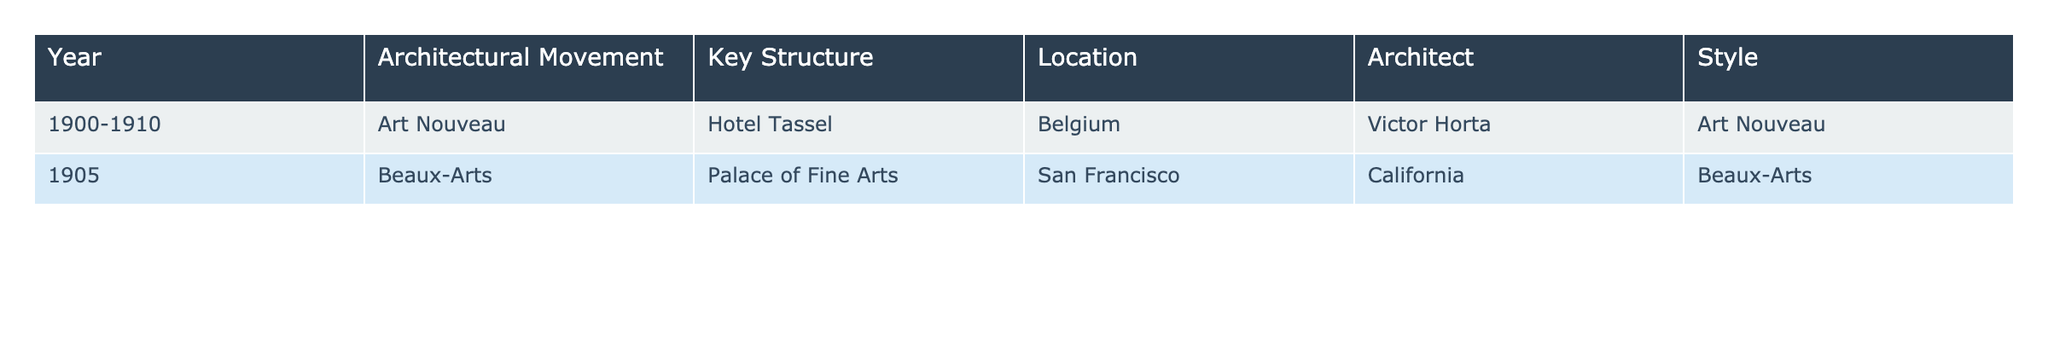What architectural movement does the Hotel Tassel represent? The table lists the Hotel Tassel under the column "Architectural Movement," which specifies that it is part of the Art Nouveau movement.
Answer: Art Nouveau Which architect designed the Palace of Fine Arts? By looking at the entry for the Palace of Fine Arts in the table, we see the architect listed is California.
Answer: California In what year was the Hotel Tassel completed? The table provides the year range for the Hotel Tassel as 1900-1910. This indicates that it was completed sometime during this period.
Answer: 1900-1910 How many architectural movements are represented in the table? The table contains two distinct architectural movements: Art Nouveau and Beaux-Arts, which is easily countable from the entries.
Answer: 2 Is the Palace of Fine Arts a key structure of the Beaux-Arts architectural movement? Yes, the table explicitly states that the Palace of Fine Arts is associated with the Beaux-Arts movement.
Answer: Yes What is the location of the structure designed by Victor Horta? The table shows that the Hotel Tassel, designed by Victor Horta, is located in Belgium.
Answer: Belgium Which style is associated with the architectural movement that occurred in 1905? The table indicates that the Beaux-Arts movement occurred in 1905, as noted in the row for the Palace of Fine Arts. So, the associated style is Beaux-Arts.
Answer: Beaux-Arts Identify the architect who created the key structure in the Art Nouveau movement. By checking the table, we see that Victor Horta is the architect of the Hotel Tassel, which is the key structure for Art Nouveau.
Answer: Victor Horta What is the difference in years between the earliest and latest structures listed? The earliest structure (Hotel Tassel) was completed around 1900, and the latest one listed (Palace of Fine Arts) is from 1905. Therefore, the difference is 1905 - 1900 = 5 years.
Answer: 5 years Are there any key structures in the table located outside of Europe? Yes, the Palace of Fine Arts is located in San Francisco, California, which is outside of Europe.
Answer: Yes How many key structures were built before 1910? The table shows two structures: Hotel Tassel (1900-1910) and Palace of Fine Arts (1905). Both were completed before 1910. Thus, the count is 2 structures.
Answer: 2 structures 